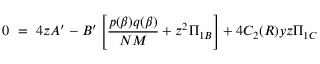<formula> <loc_0><loc_0><loc_500><loc_500>0 = 4 z A ^ { \prime } - B ^ { \prime } \left [ \frac { p ( \beta ) q ( \beta ) } { N M } + z ^ { 2 } \Pi _ { 1 B } \right ] + 4 C _ { 2 } ( R ) y z \Pi _ { 1 C }</formula> 